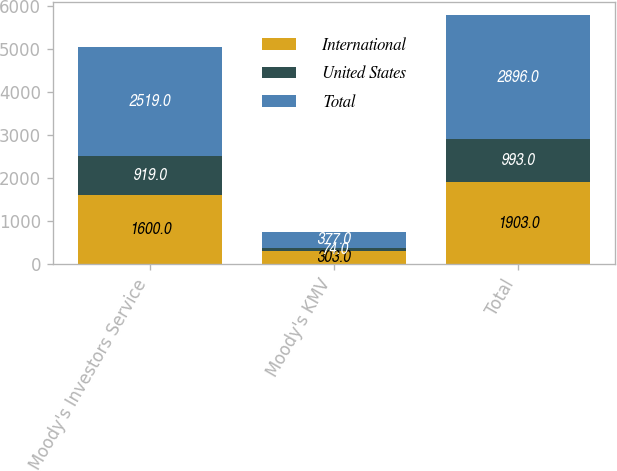Convert chart. <chart><loc_0><loc_0><loc_500><loc_500><stacked_bar_chart><ecel><fcel>Moody's Investors Service<fcel>Moody's KMV<fcel>Total<nl><fcel>International<fcel>1600<fcel>303<fcel>1903<nl><fcel>United States<fcel>919<fcel>74<fcel>993<nl><fcel>Total<fcel>2519<fcel>377<fcel>2896<nl></chart> 